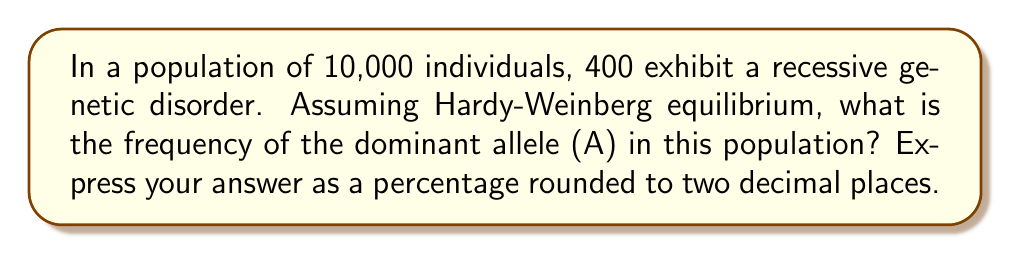Teach me how to tackle this problem. Let's approach this step-by-step using the Hardy-Weinberg principle:

1) Let p = frequency of dominant allele (A)
   Let q = frequency of recessive allele (a)

2) We know that p + q = 1

3) The frequency of individuals with the recessive disorder (aa) is q^2:
   
   $q^2 = \frac{400}{10000} = 0.04$

4) To find q, we take the square root:
   
   $q = \sqrt{0.04} = 0.2$

5) Since p + q = 1, we can find p:
   
   $p = 1 - q = 1 - 0.2 = 0.8$

6) To convert to a percentage, we multiply by 100:
   
   $0.8 * 100 = 80\%$

Therefore, the frequency of the dominant allele (A) is 80.00%.
Answer: 80.00% 